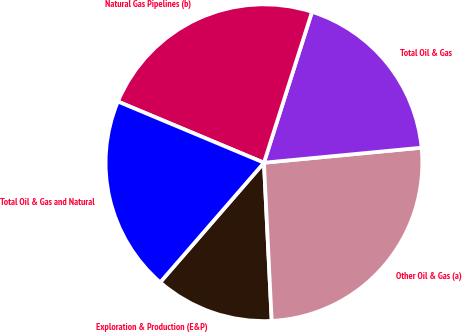Convert chart to OTSL. <chart><loc_0><loc_0><loc_500><loc_500><pie_chart><fcel>Exploration & Production (E&P)<fcel>Other Oil & Gas (a)<fcel>Total Oil & Gas<fcel>Natural Gas Pipelines (b)<fcel>Total Oil & Gas and Natural<nl><fcel>12.15%<fcel>25.73%<fcel>18.58%<fcel>23.59%<fcel>19.94%<nl></chart> 